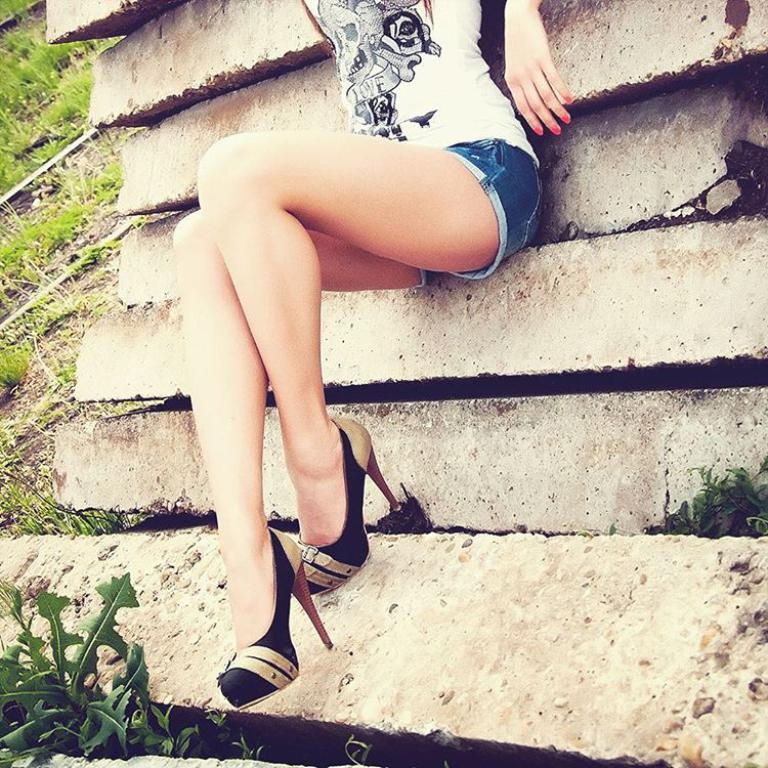Who or what is present in the image? There is a person in the image. What is the person standing on? The person is on stones. What type of vegetation can be seen in the image? There is grass and a plant in the image. How many apples and pears are visible in the image? There are no apples or pears present in the image. 